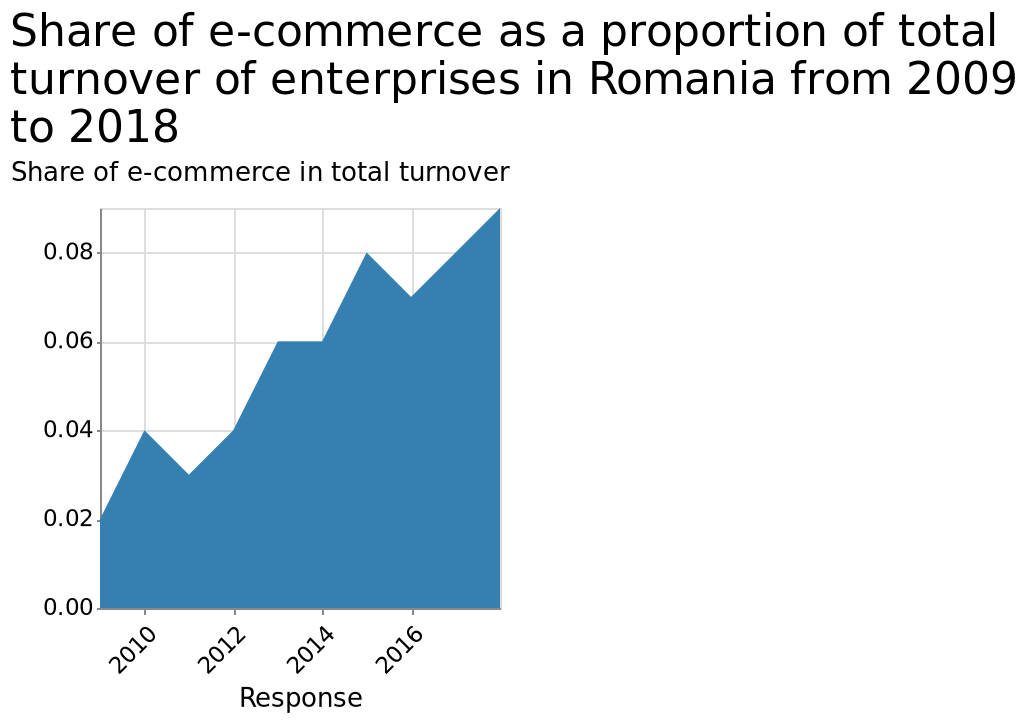<image>
Has there been any significant change in turnover over the years?  No significant changes have been observed in turnover. 